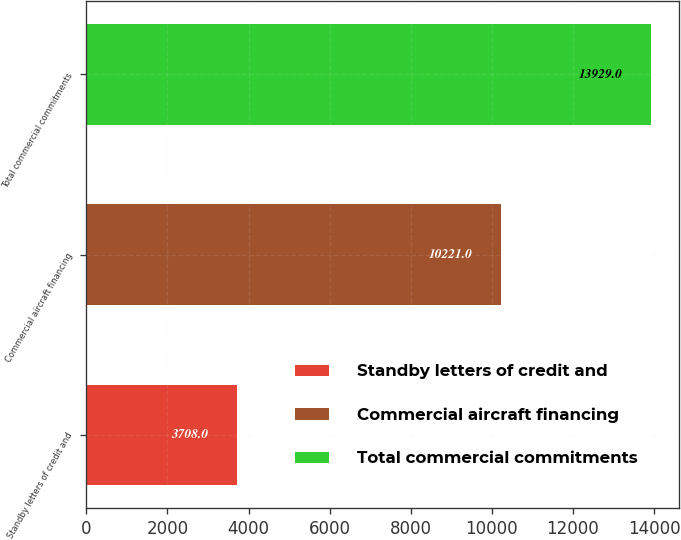<chart> <loc_0><loc_0><loc_500><loc_500><bar_chart><fcel>Standby letters of credit and<fcel>Commercial aircraft financing<fcel>Total commercial commitments<nl><fcel>3708<fcel>10221<fcel>13929<nl></chart> 